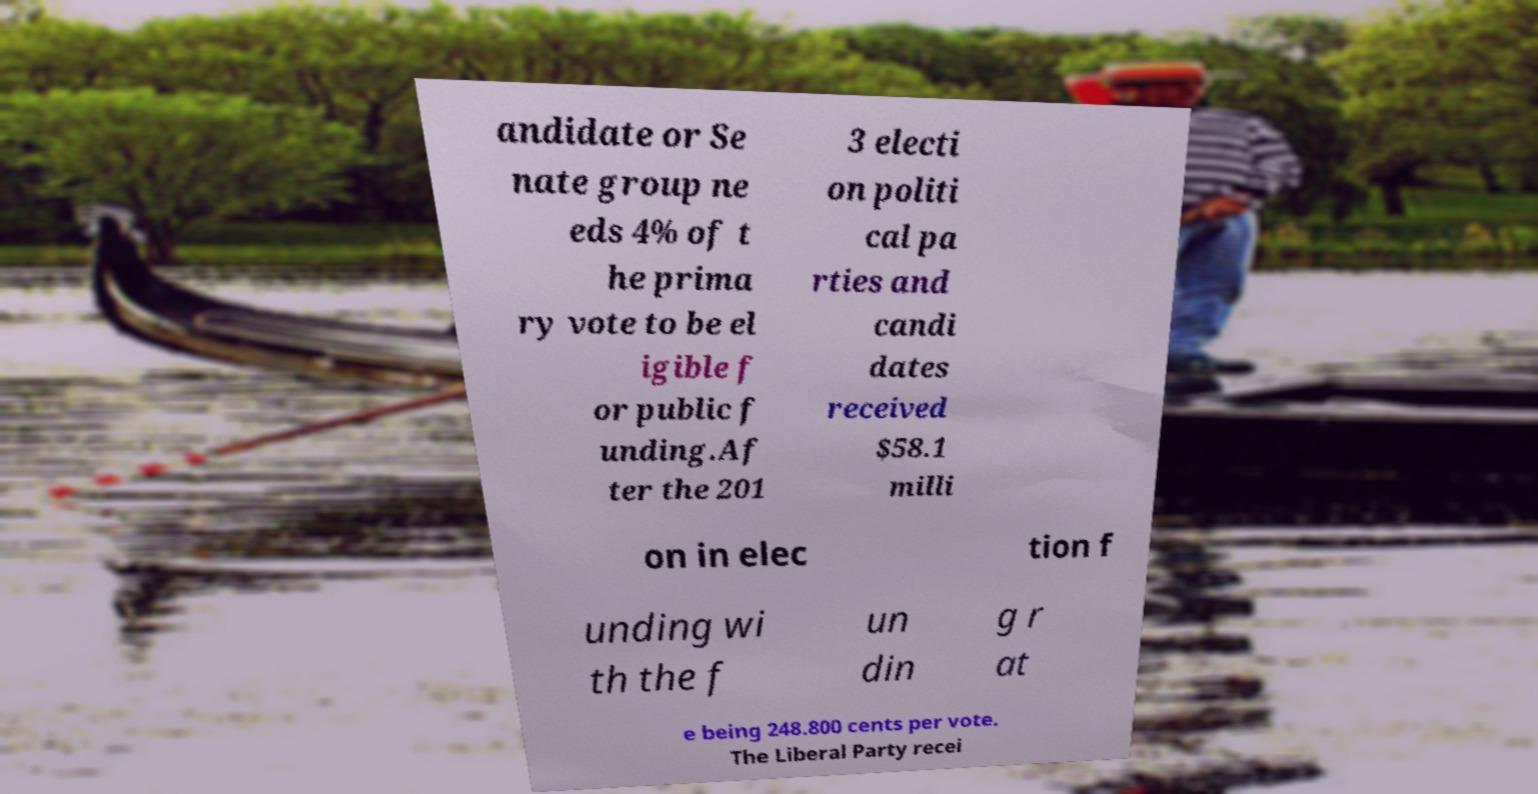Could you assist in decoding the text presented in this image and type it out clearly? andidate or Se nate group ne eds 4% of t he prima ry vote to be el igible f or public f unding.Af ter the 201 3 electi on politi cal pa rties and candi dates received $58.1 milli on in elec tion f unding wi th the f un din g r at e being 248.800 cents per vote. The Liberal Party recei 